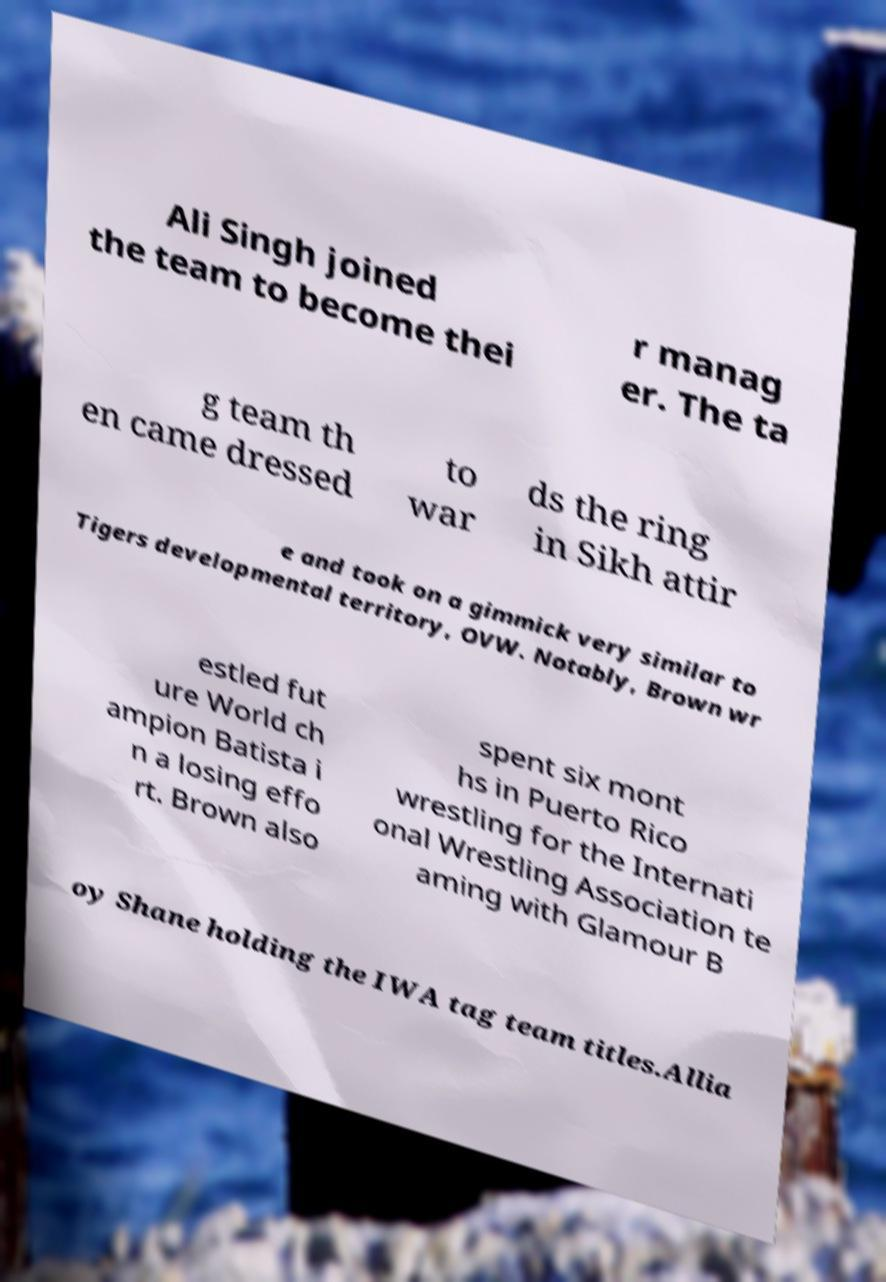What messages or text are displayed in this image? I need them in a readable, typed format. Ali Singh joined the team to become thei r manag er. The ta g team th en came dressed to war ds the ring in Sikh attir e and took on a gimmick very similar to Tigers developmental territory, OVW. Notably, Brown wr estled fut ure World ch ampion Batista i n a losing effo rt. Brown also spent six mont hs in Puerto Rico wrestling for the Internati onal Wrestling Association te aming with Glamour B oy Shane holding the IWA tag team titles.Allia 